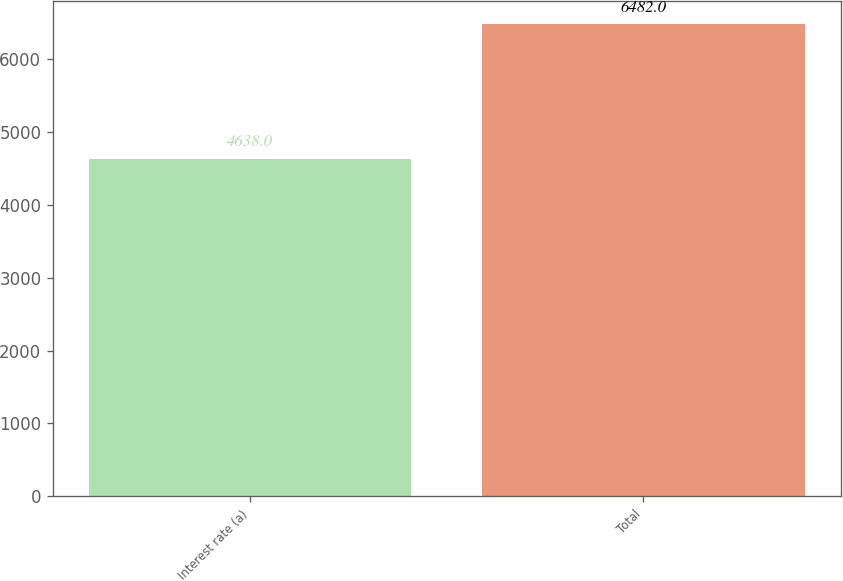<chart> <loc_0><loc_0><loc_500><loc_500><bar_chart><fcel>Interest rate (a)<fcel>Total<nl><fcel>4638<fcel>6482<nl></chart> 